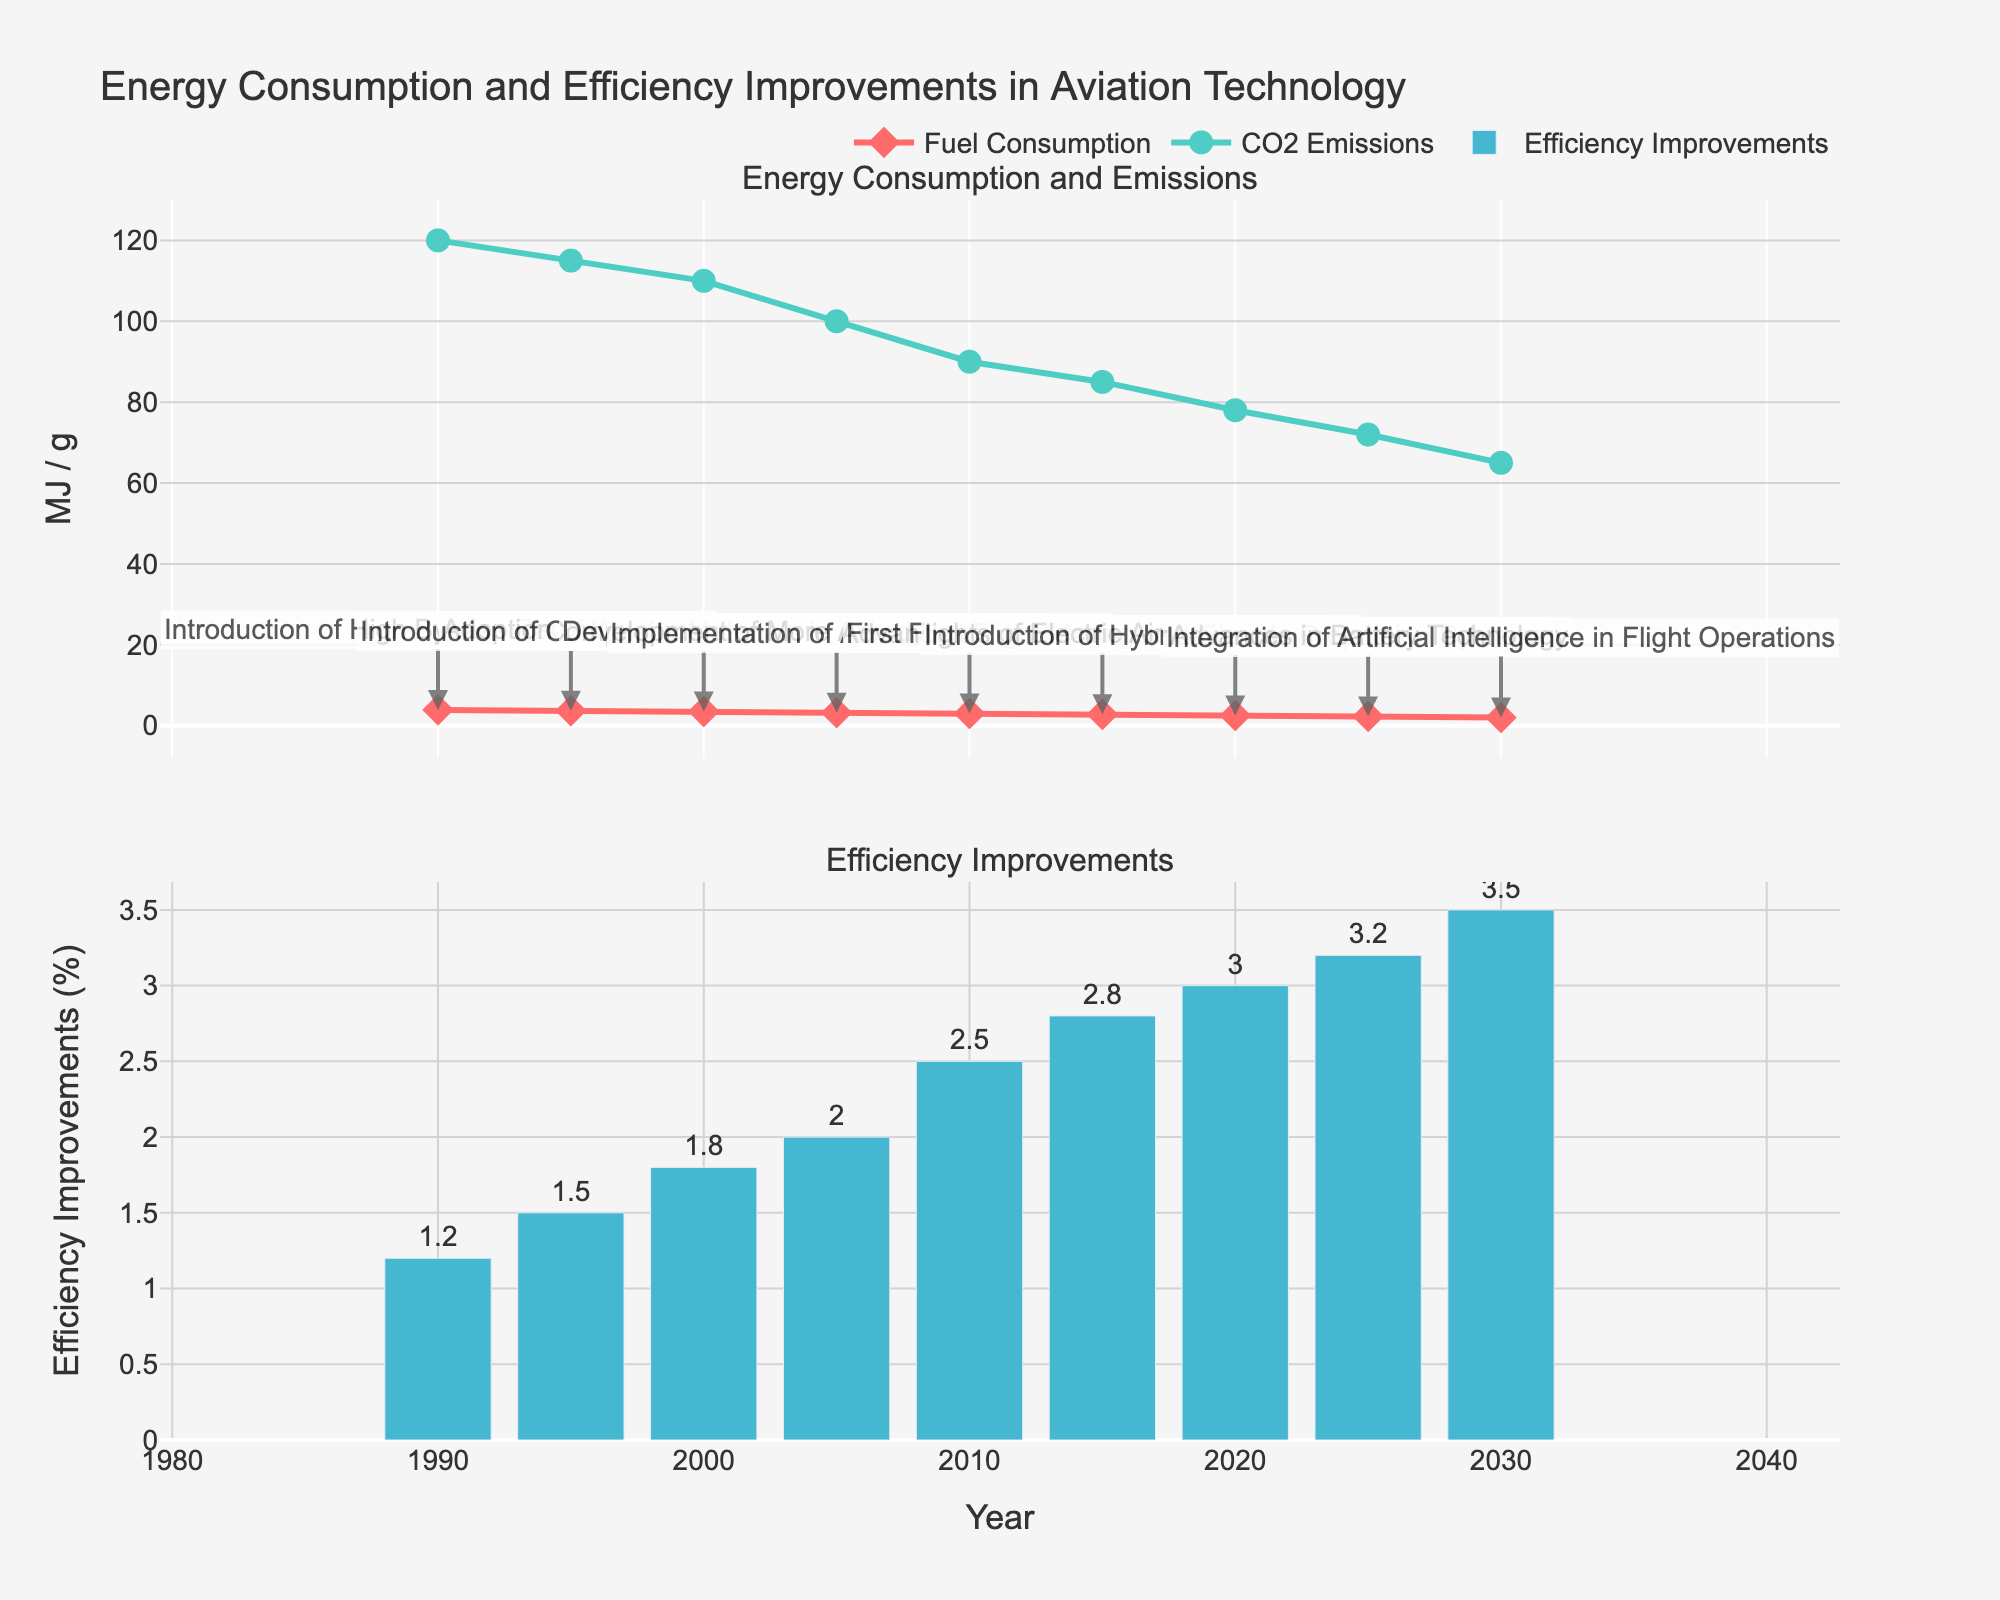What does the title of the figure indicate? The title "Energy Consumption and Efficiency Improvements in Aviation Technology" indicates that the figure is about the changes in energy consumption, CO2 emissions, and efficiency improvements in aviation technology over time.
Answer: Changes in energy consumption, CO2 emissions, and efficiency improvements in aviation technology over time What are the units used for Fuel Consumption and CO2 Emissions on the y-axis? The y-axis for Fuel Consumption is labeled in MJ (MegaJoules) per Seat Mile, and the y-axis for CO2 Emissions is labeled in grams (g) per Seat Mile.
Answer: MJ per Seat Mile and grams per Seat Mile What year had the highest percentage of Efficiency Improvements? To find the year with the highest percentage of Efficiency Improvements, look for the tallest bar in the bottom plot. The tallest bar appears in 2030 with a value of 3.5%.
Answer: 2030 Between which years does the CO2 Emission Per Seat Mile drop significantly? To determine the significant drop, observe the lines representing CO2 Emissions and identify sharp declines. The most substantial drop occurs between 2000 and 2020.
Answer: 2000 and 2020 What major development occurred in 2015 and what was its impact? In 2015, the major development was the "First Flights of Electric Aircraft Prototypes," and its impact is reflected in further reduction of Fuel Consumption and CO2 Emissions.
Answer: First Flights of Electric Aircraft Prototypes, decrease in Fuel Consumption and CO2 Emissions How much lower was the Fuel Consumption Per Seat Mile in 2025 compared to 1990? From the figure, Fuel Consumption in 2025 is 2.3 MJ, and in 1990 it is 3.9 MJ. The difference is 3.9 - 2.3 = 1.6 MJ.
Answer: 1.6 MJ Compare the Fuel Consumption Per Seat Mile between 1990 and 2000. The Fuel Consumption decreased from 3.9 MJ in 1990 to 3.5 MJ in 2000. Thus, there was a reduction of 0.4 MJ over the decade.
Answer: A reduction of 0.4 MJ What were the Efficiency Improvements in 2005 and how significant were they compared to 2010? Efficiency Improvements in 2005 were 2.0%, while in 2010 they were 2.5%. The improvement difference is 2.5% - 2.0% = 0.5%.
Answer: 0.5% How many major developments are annotated in the figure? Count the number of text annotations linked to data points for each major development. There are a total of 9 annotations.
Answer: 9 What was the trend in CO2 Emissions Per Seat Mile after the introduction of Hybrid-Electric Propulsion Systems in 2020? Following the 2020 introduction of Hybrid-Electric Propulsion Systems, CO2 Emissions Per Seat Mile continued to decrease moving towards 2030.
Answer: Continued to decrease 